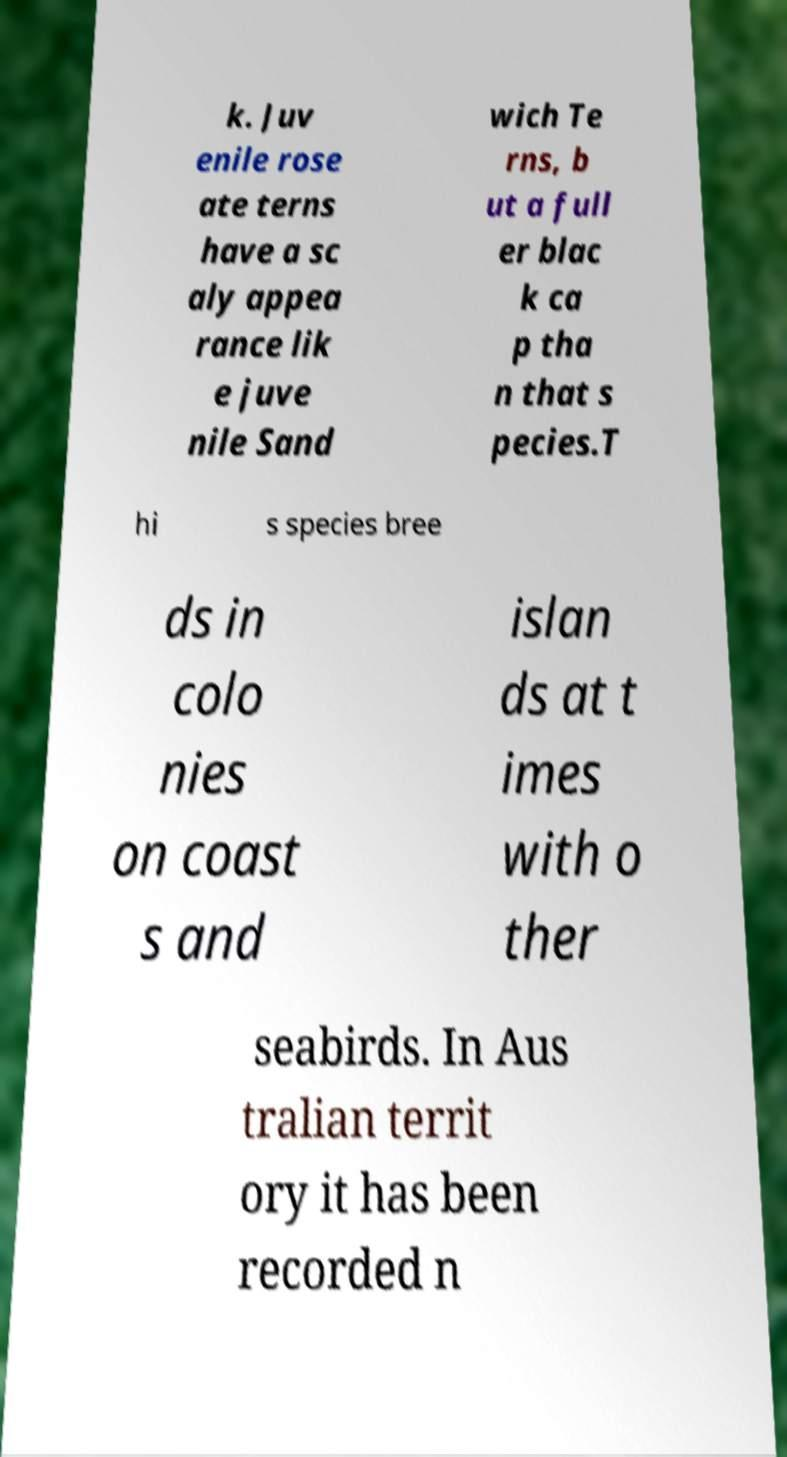I need the written content from this picture converted into text. Can you do that? k. Juv enile rose ate terns have a sc aly appea rance lik e juve nile Sand wich Te rns, b ut a full er blac k ca p tha n that s pecies.T hi s species bree ds in colo nies on coast s and islan ds at t imes with o ther seabirds. In Aus tralian territ ory it has been recorded n 